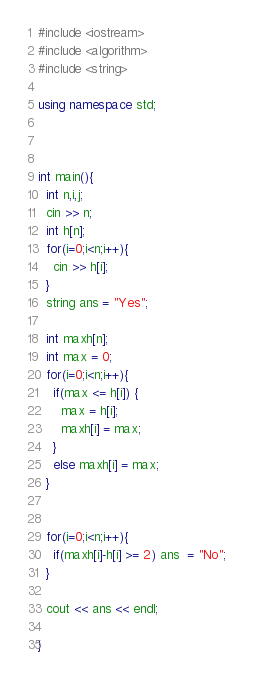<code> <loc_0><loc_0><loc_500><loc_500><_C++_>#include <iostream>
#include <algorithm>
#include <string>

using namespace std;



int main(){
  int n,i,j;
  cin >> n;
  int h[n];
  for(i=0;i<n;i++){
    cin >> h[i];
  }
  string ans = "Yes";

  int maxh[n];
  int max = 0;
  for(i=0;i<n;i++){
    if(max <= h[i]) {
      max = h[i];
      maxh[i] = max;
    }
    else maxh[i] = max;
  }


  for(i=0;i<n;i++){
    if(maxh[i]-h[i] >= 2) ans  = "No";
  }

  cout << ans << endl;

}</code> 